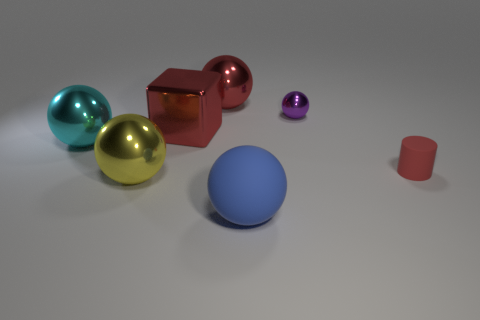Subtract 2 spheres. How many spheres are left? 3 Subtract all gray spheres. Subtract all green cylinders. How many spheres are left? 5 Add 3 blue matte things. How many objects exist? 10 Subtract all cylinders. How many objects are left? 6 Subtract all yellow spheres. Subtract all tiny purple things. How many objects are left? 5 Add 2 small objects. How many small objects are left? 4 Add 4 big gray matte spheres. How many big gray matte spheres exist? 4 Subtract 0 green cylinders. How many objects are left? 7 